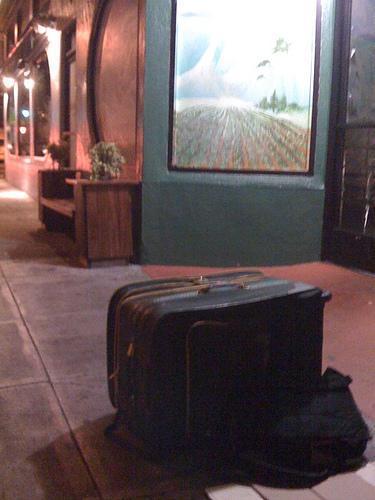How many suitcases are there?
Give a very brief answer. 1. 